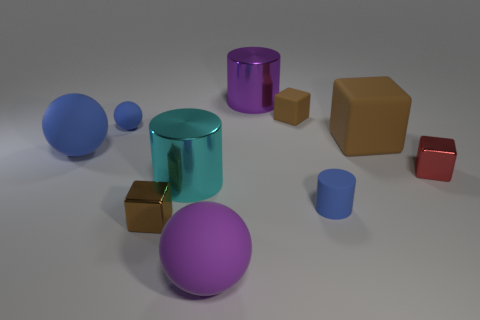Subtract all brown blocks. How many were subtracted if there are1brown blocks left? 2 Subtract all large shiny cylinders. How many cylinders are left? 1 Subtract all red cubes. How many cubes are left? 3 Subtract all cylinders. How many objects are left? 7 Subtract 4 blocks. How many blocks are left? 0 Subtract all red cubes. How many cyan cylinders are left? 1 Subtract all large matte objects. Subtract all cyan shiny cylinders. How many objects are left? 6 Add 8 large brown rubber blocks. How many large brown rubber blocks are left? 9 Add 9 blue rubber cylinders. How many blue rubber cylinders exist? 10 Subtract 1 brown cubes. How many objects are left? 9 